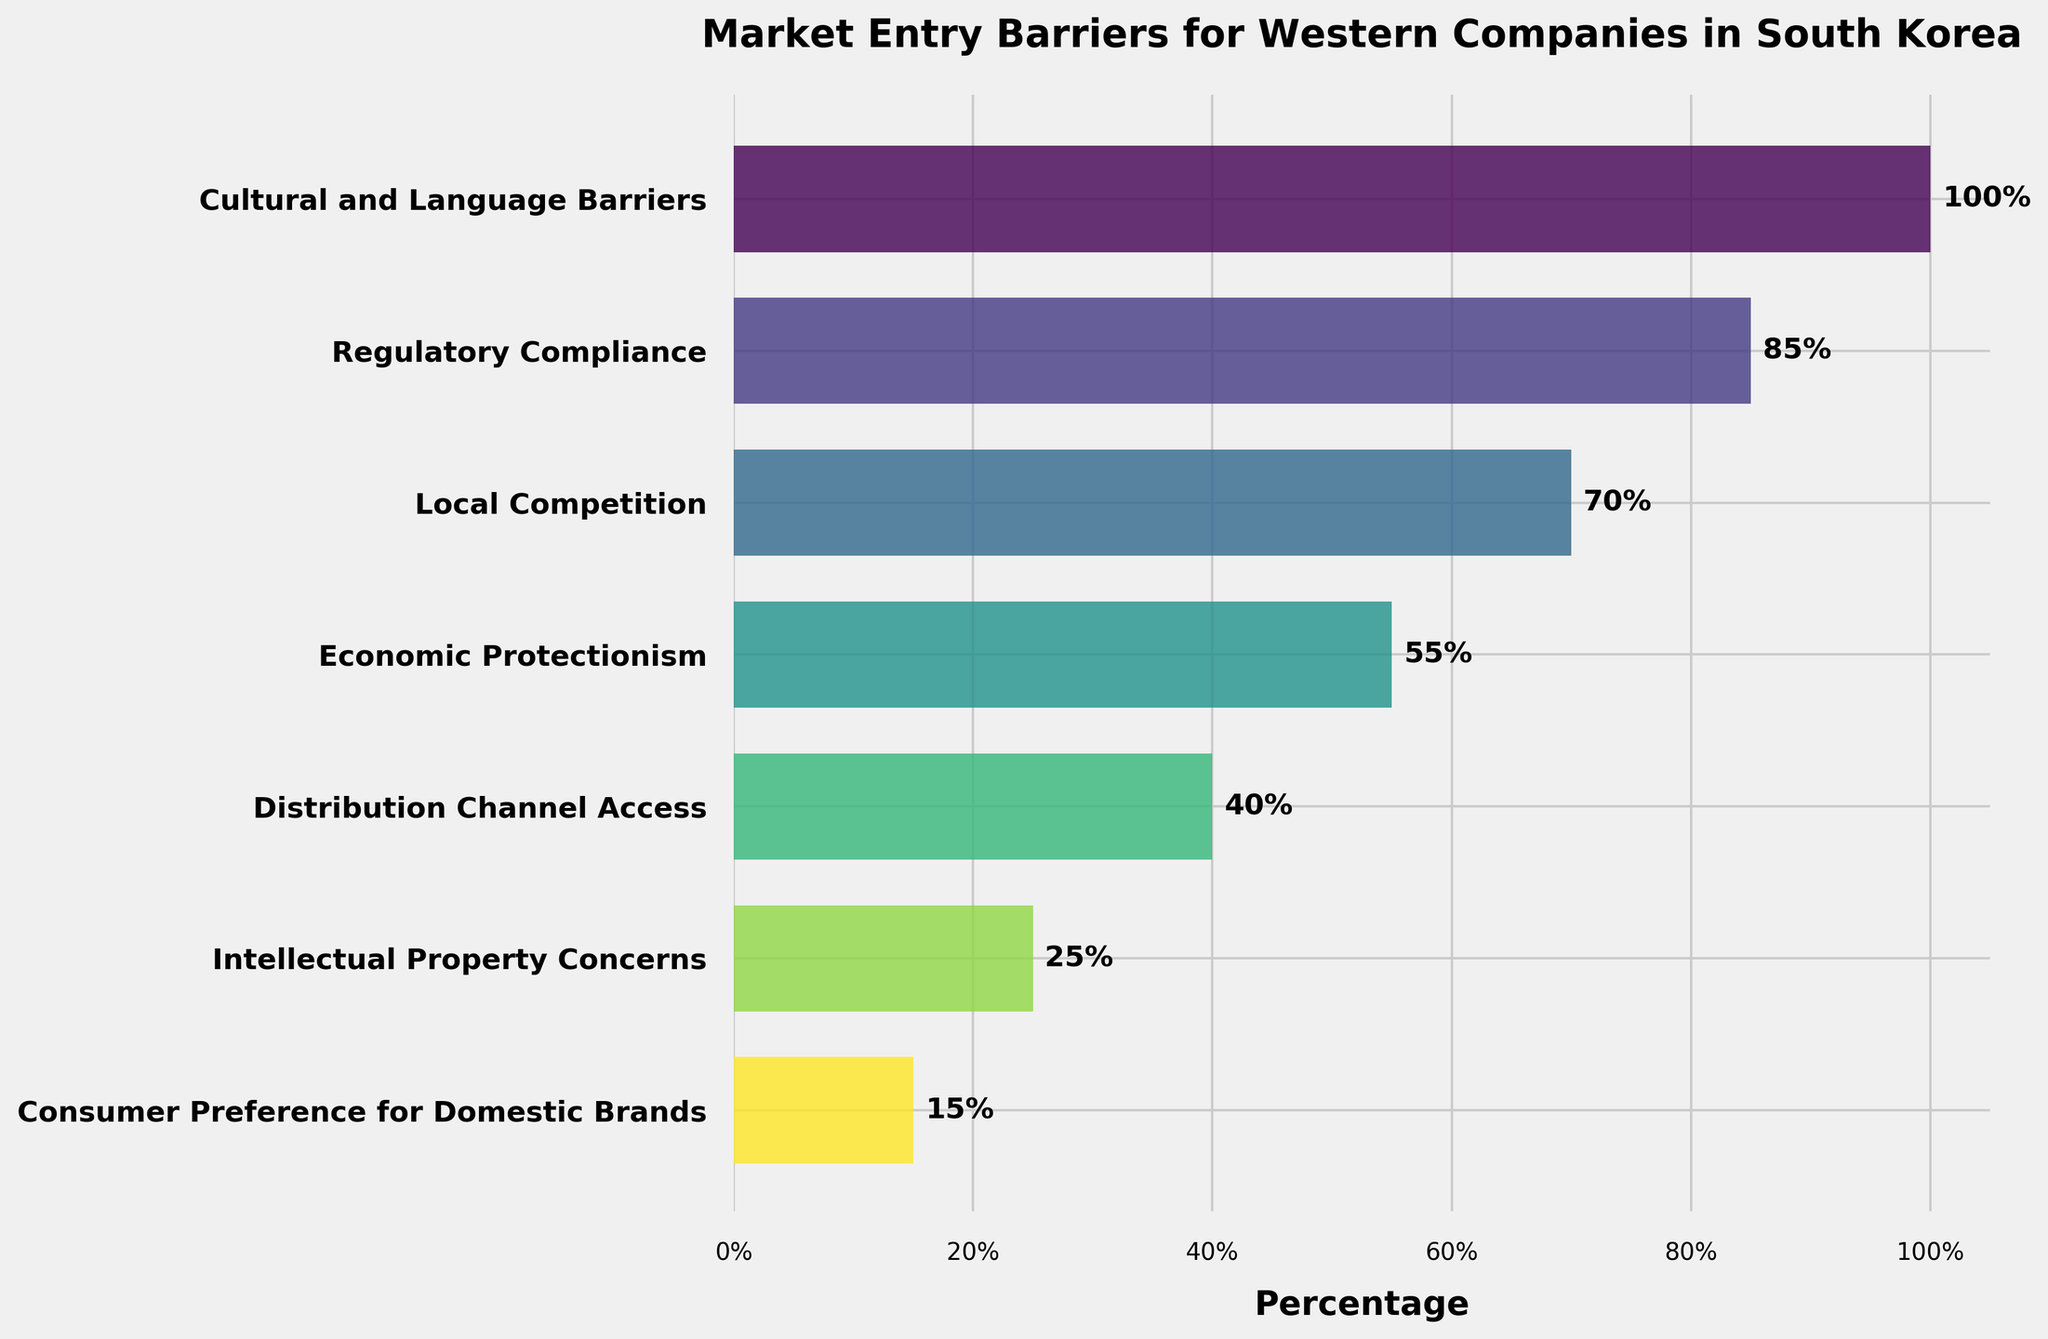What's the title of the funnel chart? You can see the title at the top of the funnel chart. It reads "Market Entry Barriers for Western Companies in South Korea"
Answer: Market Entry Barriers for Western Companies in South Korea Which stage has the highest percentage? By looking at the chart, the first stage "Cultural and Language Barriers" has the highest percentage of 100%
Answer: Cultural and Language Barriers How many stages are included in the funnel chart? By counting the stages listed on the y-axis, there are 7 stages in total
Answer: 7 What percentage points separate "Regulatory Compliance" and "Local Competition"? "Regulatory Compliance" is at 85%, and "Local Competition" is at 70%. The difference is 85% - 70%
Answer: 15% Which stage has the lowest percentage? At the bottom of the chart, the stage "Consumer Preference for Domestic Brands" has the lowest percentage of 15%
Answer: Consumer Preference for Domestic Brands What is the combined percentage of the two middle stages "Economic Protectionism" and "Distribution Channel Access"? "Economic Protectionism" is 55% and "Distribution Channel Access" is 40%. The combined percentage is 55% + 40%
Answer: 95% What is the average percentage across all the stages? Add all the percentages: 100% + 85% + 70% + 55% + 40% + 25% + 15% = 390%, then divide by the number of stages 390% / 7
Answer: 55.7% By how much is "Cultural and Language Barriers" greater than "Intellectual Property Concerns"? "Cultural and Language Barriers" is 100%, and "Intellectual Property Concerns" is 25%. The difference is 100% - 25%
Answer: 75% Which two stages have a difference of 30 percentage points? Comparing percentages, "Local Competition" (70%) and "Distribution Channel Access" (40%) have a difference of 30 percentage points
Answer: Local Competition and Distribution Channel Access What is the percentage point decrease from the stage "Cultural and Language Barriers" to the stage "Consumer Preference for Domestic Brands"? "Cultural and Language Barriers" starts at 100% and "Consumer Preference for Domestic Brands" is at 15%. The decrease is 100% - 15%
Answer: 85% 